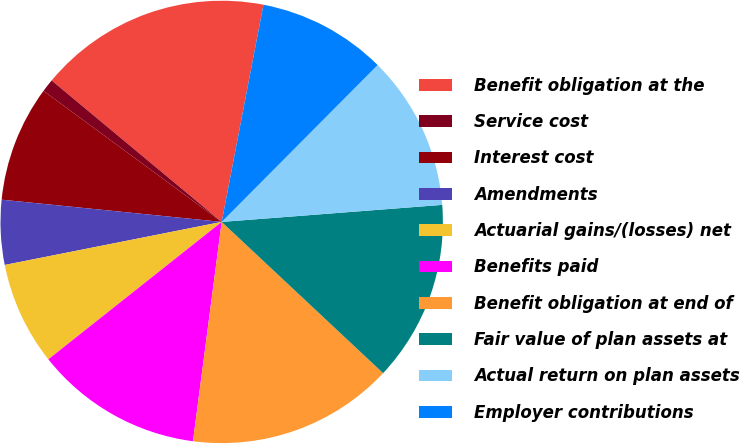<chart> <loc_0><loc_0><loc_500><loc_500><pie_chart><fcel>Benefit obligation at the<fcel>Service cost<fcel>Interest cost<fcel>Amendments<fcel>Actuarial gains/(losses) net<fcel>Benefits paid<fcel>Benefit obligation at end of<fcel>Fair value of plan assets at<fcel>Actual return on plan assets<fcel>Employer contributions<nl><fcel>16.98%<fcel>0.95%<fcel>8.49%<fcel>4.72%<fcel>7.55%<fcel>12.26%<fcel>15.09%<fcel>13.21%<fcel>11.32%<fcel>9.43%<nl></chart> 